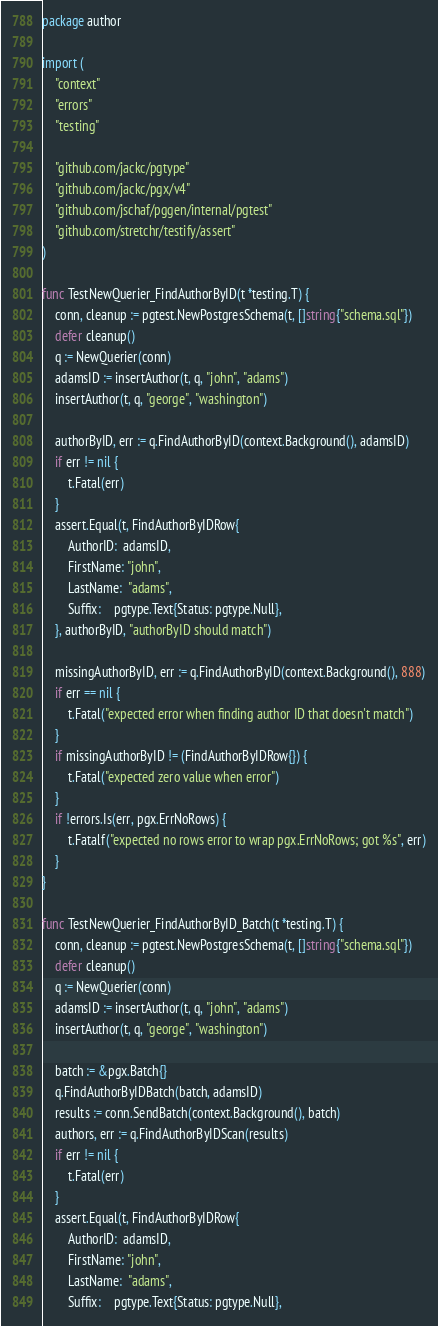<code> <loc_0><loc_0><loc_500><loc_500><_Go_>package author

import (
	"context"
	"errors"
	"testing"

	"github.com/jackc/pgtype"
	"github.com/jackc/pgx/v4"
	"github.com/jschaf/pggen/internal/pgtest"
	"github.com/stretchr/testify/assert"
)

func TestNewQuerier_FindAuthorByID(t *testing.T) {
	conn, cleanup := pgtest.NewPostgresSchema(t, []string{"schema.sql"})
	defer cleanup()
	q := NewQuerier(conn)
	adamsID := insertAuthor(t, q, "john", "adams")
	insertAuthor(t, q, "george", "washington")

	authorByID, err := q.FindAuthorByID(context.Background(), adamsID)
	if err != nil {
		t.Fatal(err)
	}
	assert.Equal(t, FindAuthorByIDRow{
		AuthorID:  adamsID,
		FirstName: "john",
		LastName:  "adams",
		Suffix:    pgtype.Text{Status: pgtype.Null},
	}, authorByID, "authorByID should match")

	missingAuthorByID, err := q.FindAuthorByID(context.Background(), 888)
	if err == nil {
		t.Fatal("expected error when finding author ID that doesn't match")
	}
	if missingAuthorByID != (FindAuthorByIDRow{}) {
		t.Fatal("expected zero value when error")
	}
	if !errors.Is(err, pgx.ErrNoRows) {
		t.Fatalf("expected no rows error to wrap pgx.ErrNoRows; got %s", err)
	}
}

func TestNewQuerier_FindAuthorByID_Batch(t *testing.T) {
	conn, cleanup := pgtest.NewPostgresSchema(t, []string{"schema.sql"})
	defer cleanup()
	q := NewQuerier(conn)
	adamsID := insertAuthor(t, q, "john", "adams")
	insertAuthor(t, q, "george", "washington")

	batch := &pgx.Batch{}
	q.FindAuthorByIDBatch(batch, adamsID)
	results := conn.SendBatch(context.Background(), batch)
	authors, err := q.FindAuthorByIDScan(results)
	if err != nil {
		t.Fatal(err)
	}
	assert.Equal(t, FindAuthorByIDRow{
		AuthorID:  adamsID,
		FirstName: "john",
		LastName:  "adams",
		Suffix:    pgtype.Text{Status: pgtype.Null},</code> 